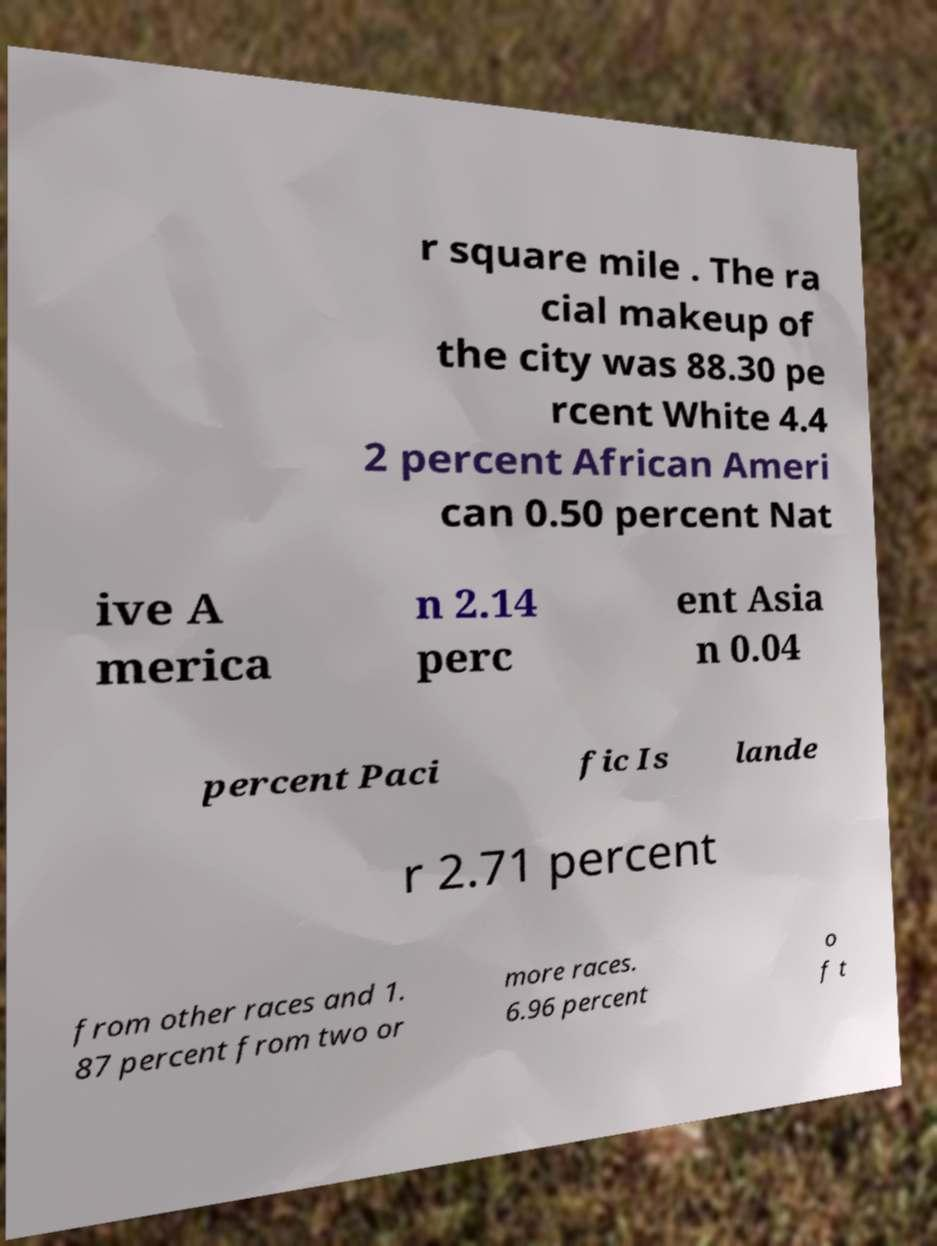Can you read and provide the text displayed in the image?This photo seems to have some interesting text. Can you extract and type it out for me? r square mile . The ra cial makeup of the city was 88.30 pe rcent White 4.4 2 percent African Ameri can 0.50 percent Nat ive A merica n 2.14 perc ent Asia n 0.04 percent Paci fic Is lande r 2.71 percent from other races and 1. 87 percent from two or more races. 6.96 percent o f t 